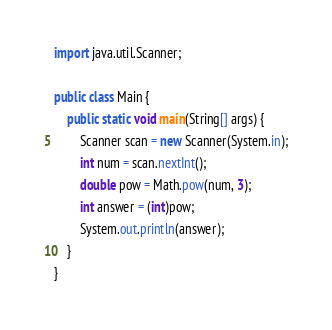<code> <loc_0><loc_0><loc_500><loc_500><_Java_>import java.util.Scanner;

public class Main {
    public static void main(String[] args) {
        Scanner scan = new Scanner(System.in);
        int num = scan.nextInt();
        double pow = Math.pow(num, 3);
        int answer = (int)pow;
        System.out.println(answer);
    }
}</code> 